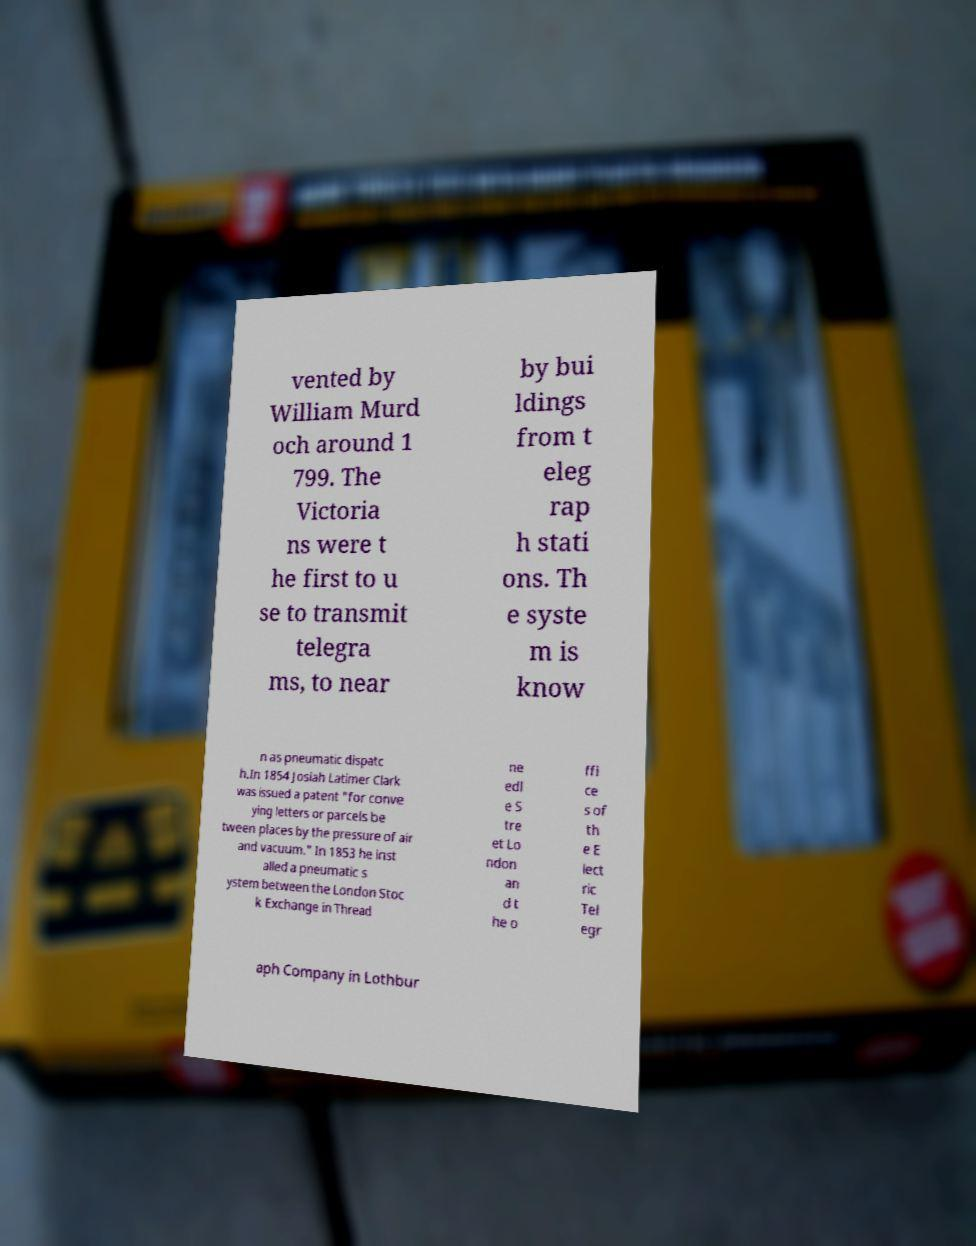Could you extract and type out the text from this image? vented by William Murd och around 1 799. The Victoria ns were t he first to u se to transmit telegra ms, to near by bui ldings from t eleg rap h stati ons. Th e syste m is know n as pneumatic dispatc h.In 1854 Josiah Latimer Clark was issued a patent "for conve ying letters or parcels be tween places by the pressure of air and vacuum." In 1853 he inst alled a pneumatic s ystem between the London Stoc k Exchange in Thread ne edl e S tre et Lo ndon an d t he o ffi ce s of th e E lect ric Tel egr aph Company in Lothbur 